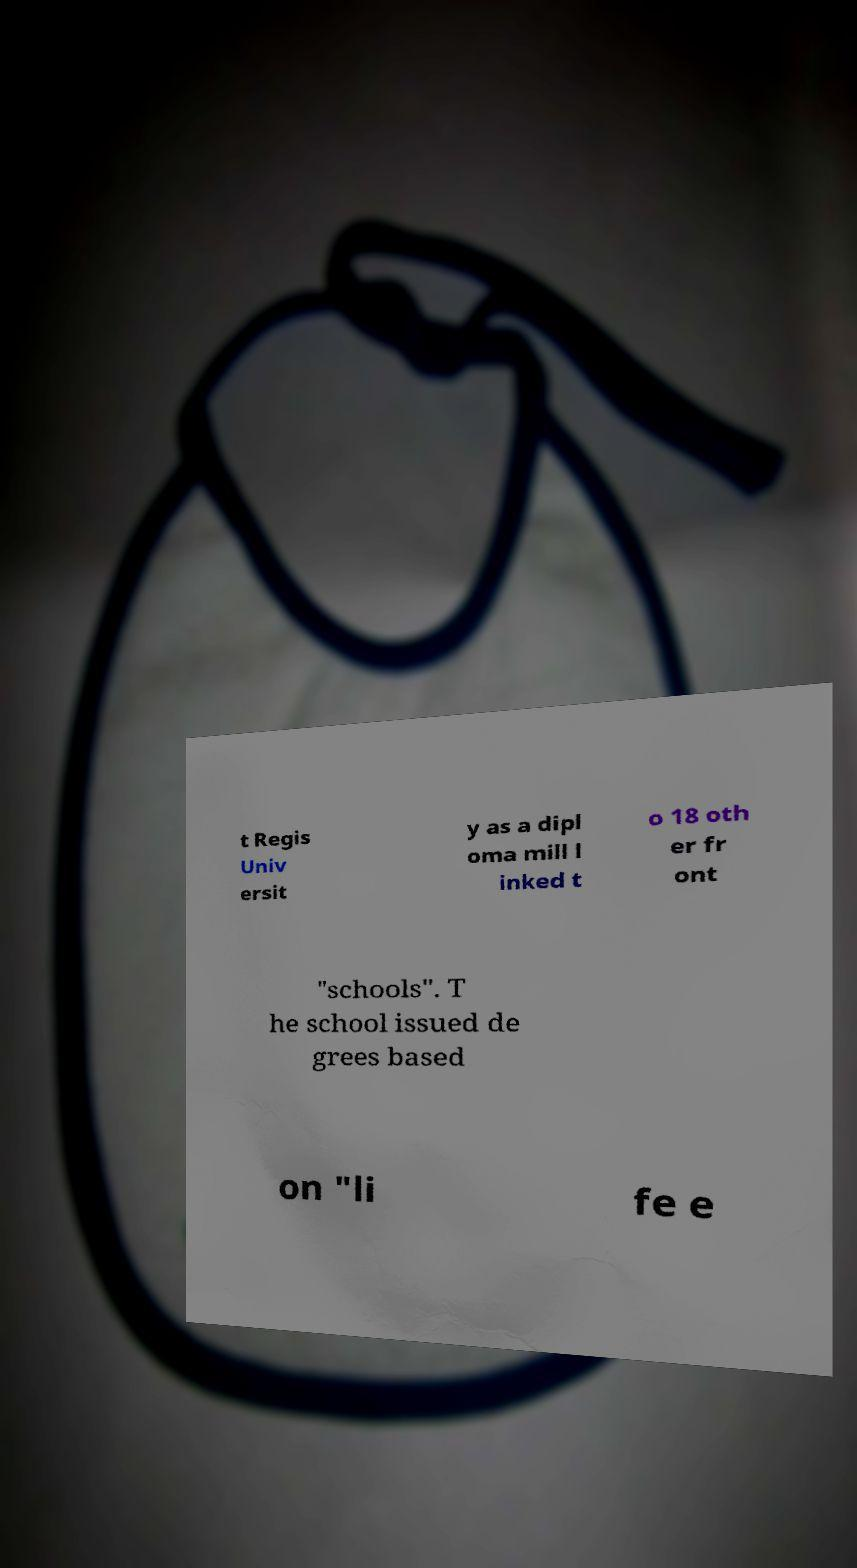For documentation purposes, I need the text within this image transcribed. Could you provide that? t Regis Univ ersit y as a dipl oma mill l inked t o 18 oth er fr ont "schools". T he school issued de grees based on "li fe e 